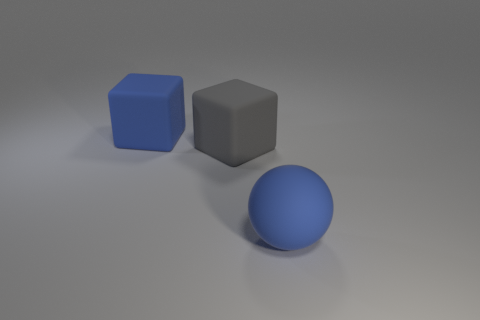Add 3 matte cubes. How many objects exist? 6 Subtract all balls. How many objects are left? 2 Add 1 gray matte cubes. How many gray matte cubes are left? 2 Add 2 large blocks. How many large blocks exist? 4 Subtract 0 brown blocks. How many objects are left? 3 Subtract all green spheres. Subtract all blue cylinders. How many spheres are left? 1 Subtract all blue matte objects. Subtract all big gray rubber blocks. How many objects are left? 0 